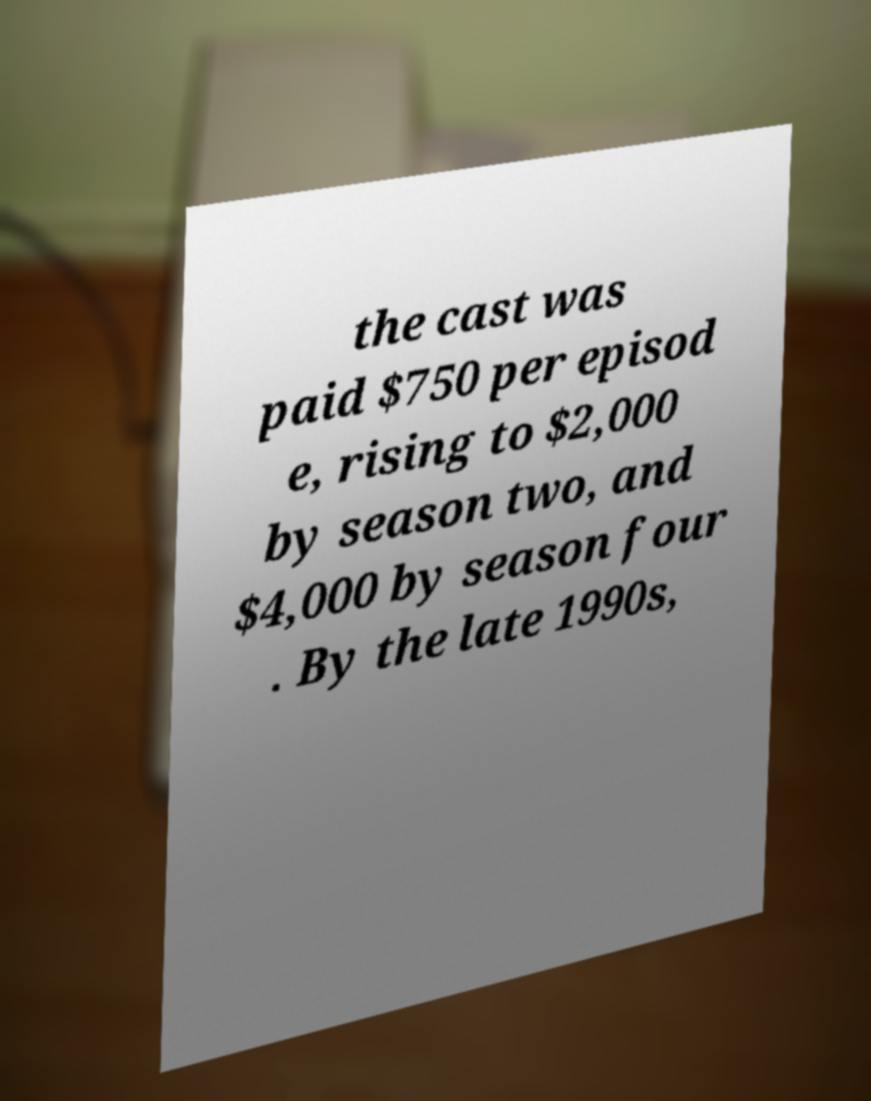There's text embedded in this image that I need extracted. Can you transcribe it verbatim? the cast was paid $750 per episod e, rising to $2,000 by season two, and $4,000 by season four . By the late 1990s, 